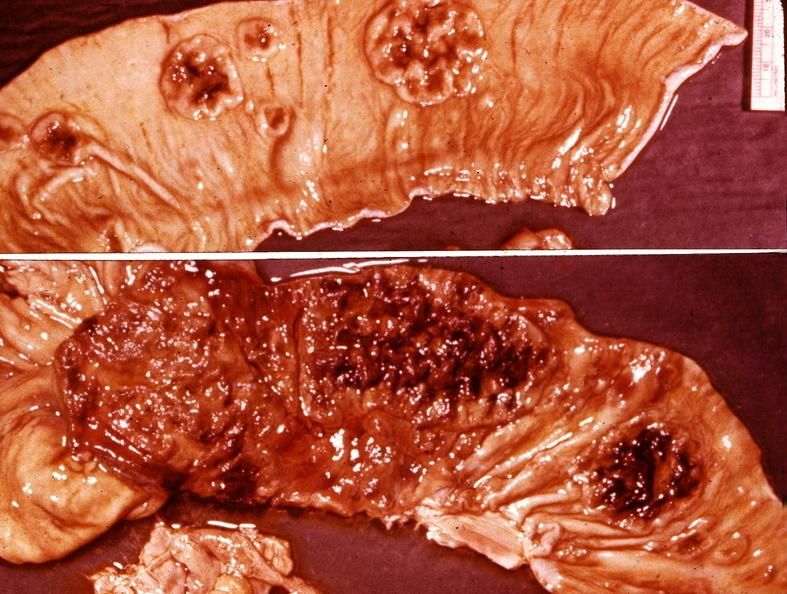what does this image show?
Answer the question using a single word or phrase. Small intestine 